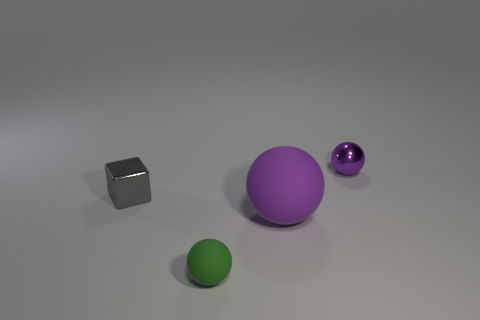Subtract all small green matte spheres. How many spheres are left? 2 Subtract all cyan cylinders. How many purple spheres are left? 2 Add 1 large purple rubber cubes. How many objects exist? 5 Subtract 1 spheres. How many spheres are left? 2 Subtract all red balls. Subtract all cyan cubes. How many balls are left? 3 Subtract all balls. How many objects are left? 1 Add 4 large purple matte objects. How many large purple matte objects are left? 5 Add 4 gray spheres. How many gray spheres exist? 4 Subtract 0 cyan blocks. How many objects are left? 4 Subtract all small green cubes. Subtract all purple metallic things. How many objects are left? 3 